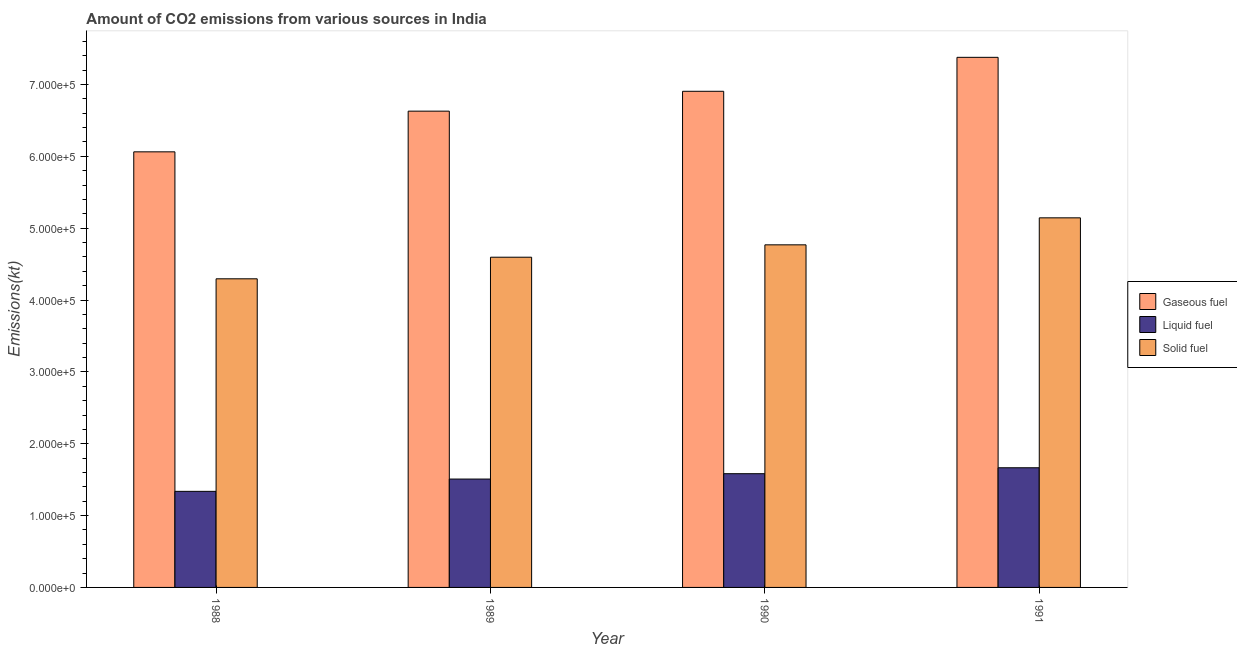How many different coloured bars are there?
Your response must be concise. 3. Are the number of bars per tick equal to the number of legend labels?
Give a very brief answer. Yes. In how many cases, is the number of bars for a given year not equal to the number of legend labels?
Ensure brevity in your answer.  0. What is the amount of co2 emissions from solid fuel in 1990?
Give a very brief answer. 4.77e+05. Across all years, what is the maximum amount of co2 emissions from solid fuel?
Offer a very short reply. 5.14e+05. Across all years, what is the minimum amount of co2 emissions from gaseous fuel?
Your response must be concise. 6.06e+05. In which year was the amount of co2 emissions from liquid fuel maximum?
Your answer should be very brief. 1991. In which year was the amount of co2 emissions from solid fuel minimum?
Make the answer very short. 1988. What is the total amount of co2 emissions from solid fuel in the graph?
Your answer should be compact. 1.88e+06. What is the difference between the amount of co2 emissions from gaseous fuel in 1989 and that in 1991?
Provide a succinct answer. -7.49e+04. What is the difference between the amount of co2 emissions from solid fuel in 1988 and the amount of co2 emissions from gaseous fuel in 1991?
Make the answer very short. -8.49e+04. What is the average amount of co2 emissions from liquid fuel per year?
Give a very brief answer. 1.52e+05. In the year 1990, what is the difference between the amount of co2 emissions from liquid fuel and amount of co2 emissions from gaseous fuel?
Provide a short and direct response. 0. In how many years, is the amount of co2 emissions from liquid fuel greater than 160000 kt?
Offer a terse response. 1. What is the ratio of the amount of co2 emissions from gaseous fuel in 1990 to that in 1991?
Your answer should be compact. 0.94. Is the amount of co2 emissions from solid fuel in 1988 less than that in 1990?
Provide a succinct answer. Yes. Is the difference between the amount of co2 emissions from solid fuel in 1988 and 1990 greater than the difference between the amount of co2 emissions from gaseous fuel in 1988 and 1990?
Offer a terse response. No. What is the difference between the highest and the second highest amount of co2 emissions from gaseous fuel?
Offer a terse response. 4.73e+04. What is the difference between the highest and the lowest amount of co2 emissions from solid fuel?
Give a very brief answer. 8.49e+04. What does the 2nd bar from the left in 1990 represents?
Offer a very short reply. Liquid fuel. What does the 2nd bar from the right in 1988 represents?
Provide a succinct answer. Liquid fuel. Is it the case that in every year, the sum of the amount of co2 emissions from gaseous fuel and amount of co2 emissions from liquid fuel is greater than the amount of co2 emissions from solid fuel?
Give a very brief answer. Yes. Are all the bars in the graph horizontal?
Make the answer very short. No. How many years are there in the graph?
Give a very brief answer. 4. Does the graph contain any zero values?
Offer a terse response. No. Where does the legend appear in the graph?
Your response must be concise. Center right. How many legend labels are there?
Keep it short and to the point. 3. What is the title of the graph?
Provide a succinct answer. Amount of CO2 emissions from various sources in India. Does "Negligence towards kids" appear as one of the legend labels in the graph?
Your answer should be very brief. No. What is the label or title of the Y-axis?
Your response must be concise. Emissions(kt). What is the Emissions(kt) in Gaseous fuel in 1988?
Give a very brief answer. 6.06e+05. What is the Emissions(kt) of Liquid fuel in 1988?
Ensure brevity in your answer.  1.34e+05. What is the Emissions(kt) in Solid fuel in 1988?
Keep it short and to the point. 4.30e+05. What is the Emissions(kt) in Gaseous fuel in 1989?
Make the answer very short. 6.63e+05. What is the Emissions(kt) of Liquid fuel in 1989?
Your answer should be very brief. 1.51e+05. What is the Emissions(kt) of Solid fuel in 1989?
Offer a terse response. 4.60e+05. What is the Emissions(kt) in Gaseous fuel in 1990?
Offer a terse response. 6.91e+05. What is the Emissions(kt) of Liquid fuel in 1990?
Give a very brief answer. 1.58e+05. What is the Emissions(kt) of Solid fuel in 1990?
Give a very brief answer. 4.77e+05. What is the Emissions(kt) of Gaseous fuel in 1991?
Your answer should be compact. 7.38e+05. What is the Emissions(kt) of Liquid fuel in 1991?
Offer a very short reply. 1.67e+05. What is the Emissions(kt) of Solid fuel in 1991?
Offer a terse response. 5.14e+05. Across all years, what is the maximum Emissions(kt) of Gaseous fuel?
Offer a terse response. 7.38e+05. Across all years, what is the maximum Emissions(kt) of Liquid fuel?
Provide a succinct answer. 1.67e+05. Across all years, what is the maximum Emissions(kt) in Solid fuel?
Your answer should be compact. 5.14e+05. Across all years, what is the minimum Emissions(kt) in Gaseous fuel?
Your answer should be very brief. 6.06e+05. Across all years, what is the minimum Emissions(kt) of Liquid fuel?
Provide a short and direct response. 1.34e+05. Across all years, what is the minimum Emissions(kt) of Solid fuel?
Provide a succinct answer. 4.30e+05. What is the total Emissions(kt) of Gaseous fuel in the graph?
Your response must be concise. 2.70e+06. What is the total Emissions(kt) of Liquid fuel in the graph?
Offer a very short reply. 6.09e+05. What is the total Emissions(kt) of Solid fuel in the graph?
Provide a succinct answer. 1.88e+06. What is the difference between the Emissions(kt) of Gaseous fuel in 1988 and that in 1989?
Provide a succinct answer. -5.66e+04. What is the difference between the Emissions(kt) of Liquid fuel in 1988 and that in 1989?
Provide a short and direct response. -1.71e+04. What is the difference between the Emissions(kt) in Solid fuel in 1988 and that in 1989?
Ensure brevity in your answer.  -3.00e+04. What is the difference between the Emissions(kt) of Gaseous fuel in 1988 and that in 1990?
Offer a terse response. -8.43e+04. What is the difference between the Emissions(kt) in Liquid fuel in 1988 and that in 1990?
Offer a terse response. -2.46e+04. What is the difference between the Emissions(kt) of Solid fuel in 1988 and that in 1990?
Offer a very short reply. -4.73e+04. What is the difference between the Emissions(kt) of Gaseous fuel in 1988 and that in 1991?
Your response must be concise. -1.32e+05. What is the difference between the Emissions(kt) in Liquid fuel in 1988 and that in 1991?
Make the answer very short. -3.28e+04. What is the difference between the Emissions(kt) in Solid fuel in 1988 and that in 1991?
Ensure brevity in your answer.  -8.49e+04. What is the difference between the Emissions(kt) in Gaseous fuel in 1989 and that in 1990?
Your answer should be very brief. -2.76e+04. What is the difference between the Emissions(kt) of Liquid fuel in 1989 and that in 1990?
Keep it short and to the point. -7458.68. What is the difference between the Emissions(kt) of Solid fuel in 1989 and that in 1990?
Your answer should be compact. -1.72e+04. What is the difference between the Emissions(kt) of Gaseous fuel in 1989 and that in 1991?
Ensure brevity in your answer.  -7.49e+04. What is the difference between the Emissions(kt) in Liquid fuel in 1989 and that in 1991?
Provide a succinct answer. -1.57e+04. What is the difference between the Emissions(kt) in Solid fuel in 1989 and that in 1991?
Keep it short and to the point. -5.48e+04. What is the difference between the Emissions(kt) in Gaseous fuel in 1990 and that in 1991?
Your answer should be compact. -4.73e+04. What is the difference between the Emissions(kt) in Liquid fuel in 1990 and that in 1991?
Offer a terse response. -8261.75. What is the difference between the Emissions(kt) in Solid fuel in 1990 and that in 1991?
Offer a very short reply. -3.76e+04. What is the difference between the Emissions(kt) of Gaseous fuel in 1988 and the Emissions(kt) of Liquid fuel in 1989?
Make the answer very short. 4.55e+05. What is the difference between the Emissions(kt) of Gaseous fuel in 1988 and the Emissions(kt) of Solid fuel in 1989?
Your answer should be very brief. 1.47e+05. What is the difference between the Emissions(kt) of Liquid fuel in 1988 and the Emissions(kt) of Solid fuel in 1989?
Keep it short and to the point. -3.26e+05. What is the difference between the Emissions(kt) in Gaseous fuel in 1988 and the Emissions(kt) in Liquid fuel in 1990?
Offer a terse response. 4.48e+05. What is the difference between the Emissions(kt) of Gaseous fuel in 1988 and the Emissions(kt) of Solid fuel in 1990?
Your response must be concise. 1.29e+05. What is the difference between the Emissions(kt) in Liquid fuel in 1988 and the Emissions(kt) in Solid fuel in 1990?
Give a very brief answer. -3.43e+05. What is the difference between the Emissions(kt) of Gaseous fuel in 1988 and the Emissions(kt) of Liquid fuel in 1991?
Keep it short and to the point. 4.40e+05. What is the difference between the Emissions(kt) of Gaseous fuel in 1988 and the Emissions(kt) of Solid fuel in 1991?
Your answer should be compact. 9.19e+04. What is the difference between the Emissions(kt) of Liquid fuel in 1988 and the Emissions(kt) of Solid fuel in 1991?
Offer a very short reply. -3.81e+05. What is the difference between the Emissions(kt) of Gaseous fuel in 1989 and the Emissions(kt) of Liquid fuel in 1990?
Provide a succinct answer. 5.05e+05. What is the difference between the Emissions(kt) in Gaseous fuel in 1989 and the Emissions(kt) in Solid fuel in 1990?
Your answer should be compact. 1.86e+05. What is the difference between the Emissions(kt) in Liquid fuel in 1989 and the Emissions(kt) in Solid fuel in 1990?
Keep it short and to the point. -3.26e+05. What is the difference between the Emissions(kt) in Gaseous fuel in 1989 and the Emissions(kt) in Liquid fuel in 1991?
Provide a short and direct response. 4.96e+05. What is the difference between the Emissions(kt) in Gaseous fuel in 1989 and the Emissions(kt) in Solid fuel in 1991?
Provide a succinct answer. 1.49e+05. What is the difference between the Emissions(kt) of Liquid fuel in 1989 and the Emissions(kt) of Solid fuel in 1991?
Your response must be concise. -3.64e+05. What is the difference between the Emissions(kt) in Gaseous fuel in 1990 and the Emissions(kt) in Liquid fuel in 1991?
Your answer should be very brief. 5.24e+05. What is the difference between the Emissions(kt) of Gaseous fuel in 1990 and the Emissions(kt) of Solid fuel in 1991?
Offer a terse response. 1.76e+05. What is the difference between the Emissions(kt) of Liquid fuel in 1990 and the Emissions(kt) of Solid fuel in 1991?
Your answer should be very brief. -3.56e+05. What is the average Emissions(kt) of Gaseous fuel per year?
Your response must be concise. 6.74e+05. What is the average Emissions(kt) of Liquid fuel per year?
Keep it short and to the point. 1.52e+05. What is the average Emissions(kt) of Solid fuel per year?
Offer a terse response. 4.70e+05. In the year 1988, what is the difference between the Emissions(kt) in Gaseous fuel and Emissions(kt) in Liquid fuel?
Keep it short and to the point. 4.73e+05. In the year 1988, what is the difference between the Emissions(kt) of Gaseous fuel and Emissions(kt) of Solid fuel?
Make the answer very short. 1.77e+05. In the year 1988, what is the difference between the Emissions(kt) of Liquid fuel and Emissions(kt) of Solid fuel?
Your answer should be compact. -2.96e+05. In the year 1989, what is the difference between the Emissions(kt) of Gaseous fuel and Emissions(kt) of Liquid fuel?
Give a very brief answer. 5.12e+05. In the year 1989, what is the difference between the Emissions(kt) of Gaseous fuel and Emissions(kt) of Solid fuel?
Offer a very short reply. 2.03e+05. In the year 1989, what is the difference between the Emissions(kt) in Liquid fuel and Emissions(kt) in Solid fuel?
Provide a short and direct response. -3.09e+05. In the year 1990, what is the difference between the Emissions(kt) of Gaseous fuel and Emissions(kt) of Liquid fuel?
Give a very brief answer. 5.32e+05. In the year 1990, what is the difference between the Emissions(kt) of Gaseous fuel and Emissions(kt) of Solid fuel?
Your answer should be compact. 2.14e+05. In the year 1990, what is the difference between the Emissions(kt) in Liquid fuel and Emissions(kt) in Solid fuel?
Your response must be concise. -3.19e+05. In the year 1991, what is the difference between the Emissions(kt) in Gaseous fuel and Emissions(kt) in Liquid fuel?
Provide a succinct answer. 5.71e+05. In the year 1991, what is the difference between the Emissions(kt) of Gaseous fuel and Emissions(kt) of Solid fuel?
Your answer should be compact. 2.23e+05. In the year 1991, what is the difference between the Emissions(kt) in Liquid fuel and Emissions(kt) in Solid fuel?
Offer a very short reply. -3.48e+05. What is the ratio of the Emissions(kt) of Gaseous fuel in 1988 to that in 1989?
Your answer should be compact. 0.91. What is the ratio of the Emissions(kt) in Liquid fuel in 1988 to that in 1989?
Make the answer very short. 0.89. What is the ratio of the Emissions(kt) of Solid fuel in 1988 to that in 1989?
Offer a very short reply. 0.93. What is the ratio of the Emissions(kt) of Gaseous fuel in 1988 to that in 1990?
Your response must be concise. 0.88. What is the ratio of the Emissions(kt) of Liquid fuel in 1988 to that in 1990?
Offer a terse response. 0.84. What is the ratio of the Emissions(kt) of Solid fuel in 1988 to that in 1990?
Your response must be concise. 0.9. What is the ratio of the Emissions(kt) in Gaseous fuel in 1988 to that in 1991?
Your response must be concise. 0.82. What is the ratio of the Emissions(kt) in Liquid fuel in 1988 to that in 1991?
Offer a very short reply. 0.8. What is the ratio of the Emissions(kt) of Solid fuel in 1988 to that in 1991?
Your answer should be very brief. 0.84. What is the ratio of the Emissions(kt) of Liquid fuel in 1989 to that in 1990?
Give a very brief answer. 0.95. What is the ratio of the Emissions(kt) of Solid fuel in 1989 to that in 1990?
Provide a short and direct response. 0.96. What is the ratio of the Emissions(kt) of Gaseous fuel in 1989 to that in 1991?
Ensure brevity in your answer.  0.9. What is the ratio of the Emissions(kt) in Liquid fuel in 1989 to that in 1991?
Ensure brevity in your answer.  0.91. What is the ratio of the Emissions(kt) of Solid fuel in 1989 to that in 1991?
Your answer should be very brief. 0.89. What is the ratio of the Emissions(kt) in Gaseous fuel in 1990 to that in 1991?
Ensure brevity in your answer.  0.94. What is the ratio of the Emissions(kt) in Liquid fuel in 1990 to that in 1991?
Your answer should be very brief. 0.95. What is the ratio of the Emissions(kt) in Solid fuel in 1990 to that in 1991?
Give a very brief answer. 0.93. What is the difference between the highest and the second highest Emissions(kt) in Gaseous fuel?
Your answer should be compact. 4.73e+04. What is the difference between the highest and the second highest Emissions(kt) in Liquid fuel?
Keep it short and to the point. 8261.75. What is the difference between the highest and the second highest Emissions(kt) of Solid fuel?
Keep it short and to the point. 3.76e+04. What is the difference between the highest and the lowest Emissions(kt) in Gaseous fuel?
Provide a short and direct response. 1.32e+05. What is the difference between the highest and the lowest Emissions(kt) in Liquid fuel?
Give a very brief answer. 3.28e+04. What is the difference between the highest and the lowest Emissions(kt) of Solid fuel?
Your answer should be very brief. 8.49e+04. 